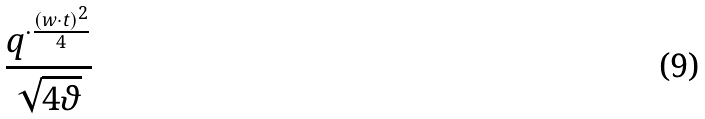Convert formula to latex. <formula><loc_0><loc_0><loc_500><loc_500>\frac { q ^ { \cdot \frac { ( w \cdot t ) ^ { 2 } } { 4 } } } { \sqrt { 4 \vartheta } }</formula> 